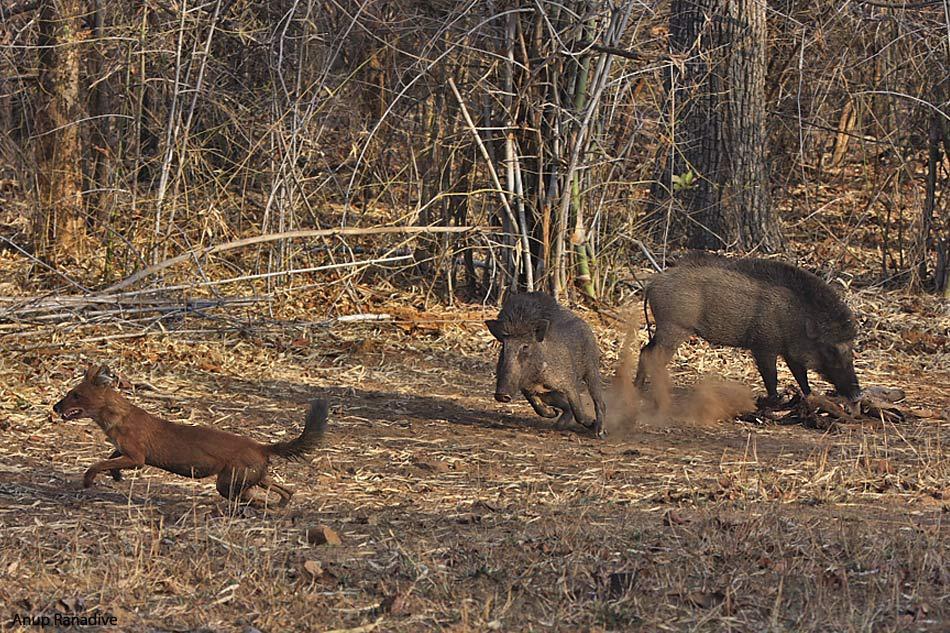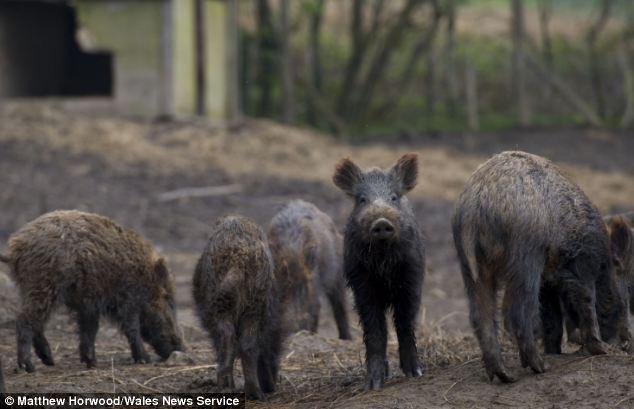The first image is the image on the left, the second image is the image on the right. Examine the images to the left and right. Is the description "There's more than one pig in each picture of the pair" accurate? Answer yes or no. Yes. The first image is the image on the left, the second image is the image on the right. Given the left and right images, does the statement "The group of at least six black and brown boars with a single bore is the middle of the group looking straight forward." hold true? Answer yes or no. Yes. 